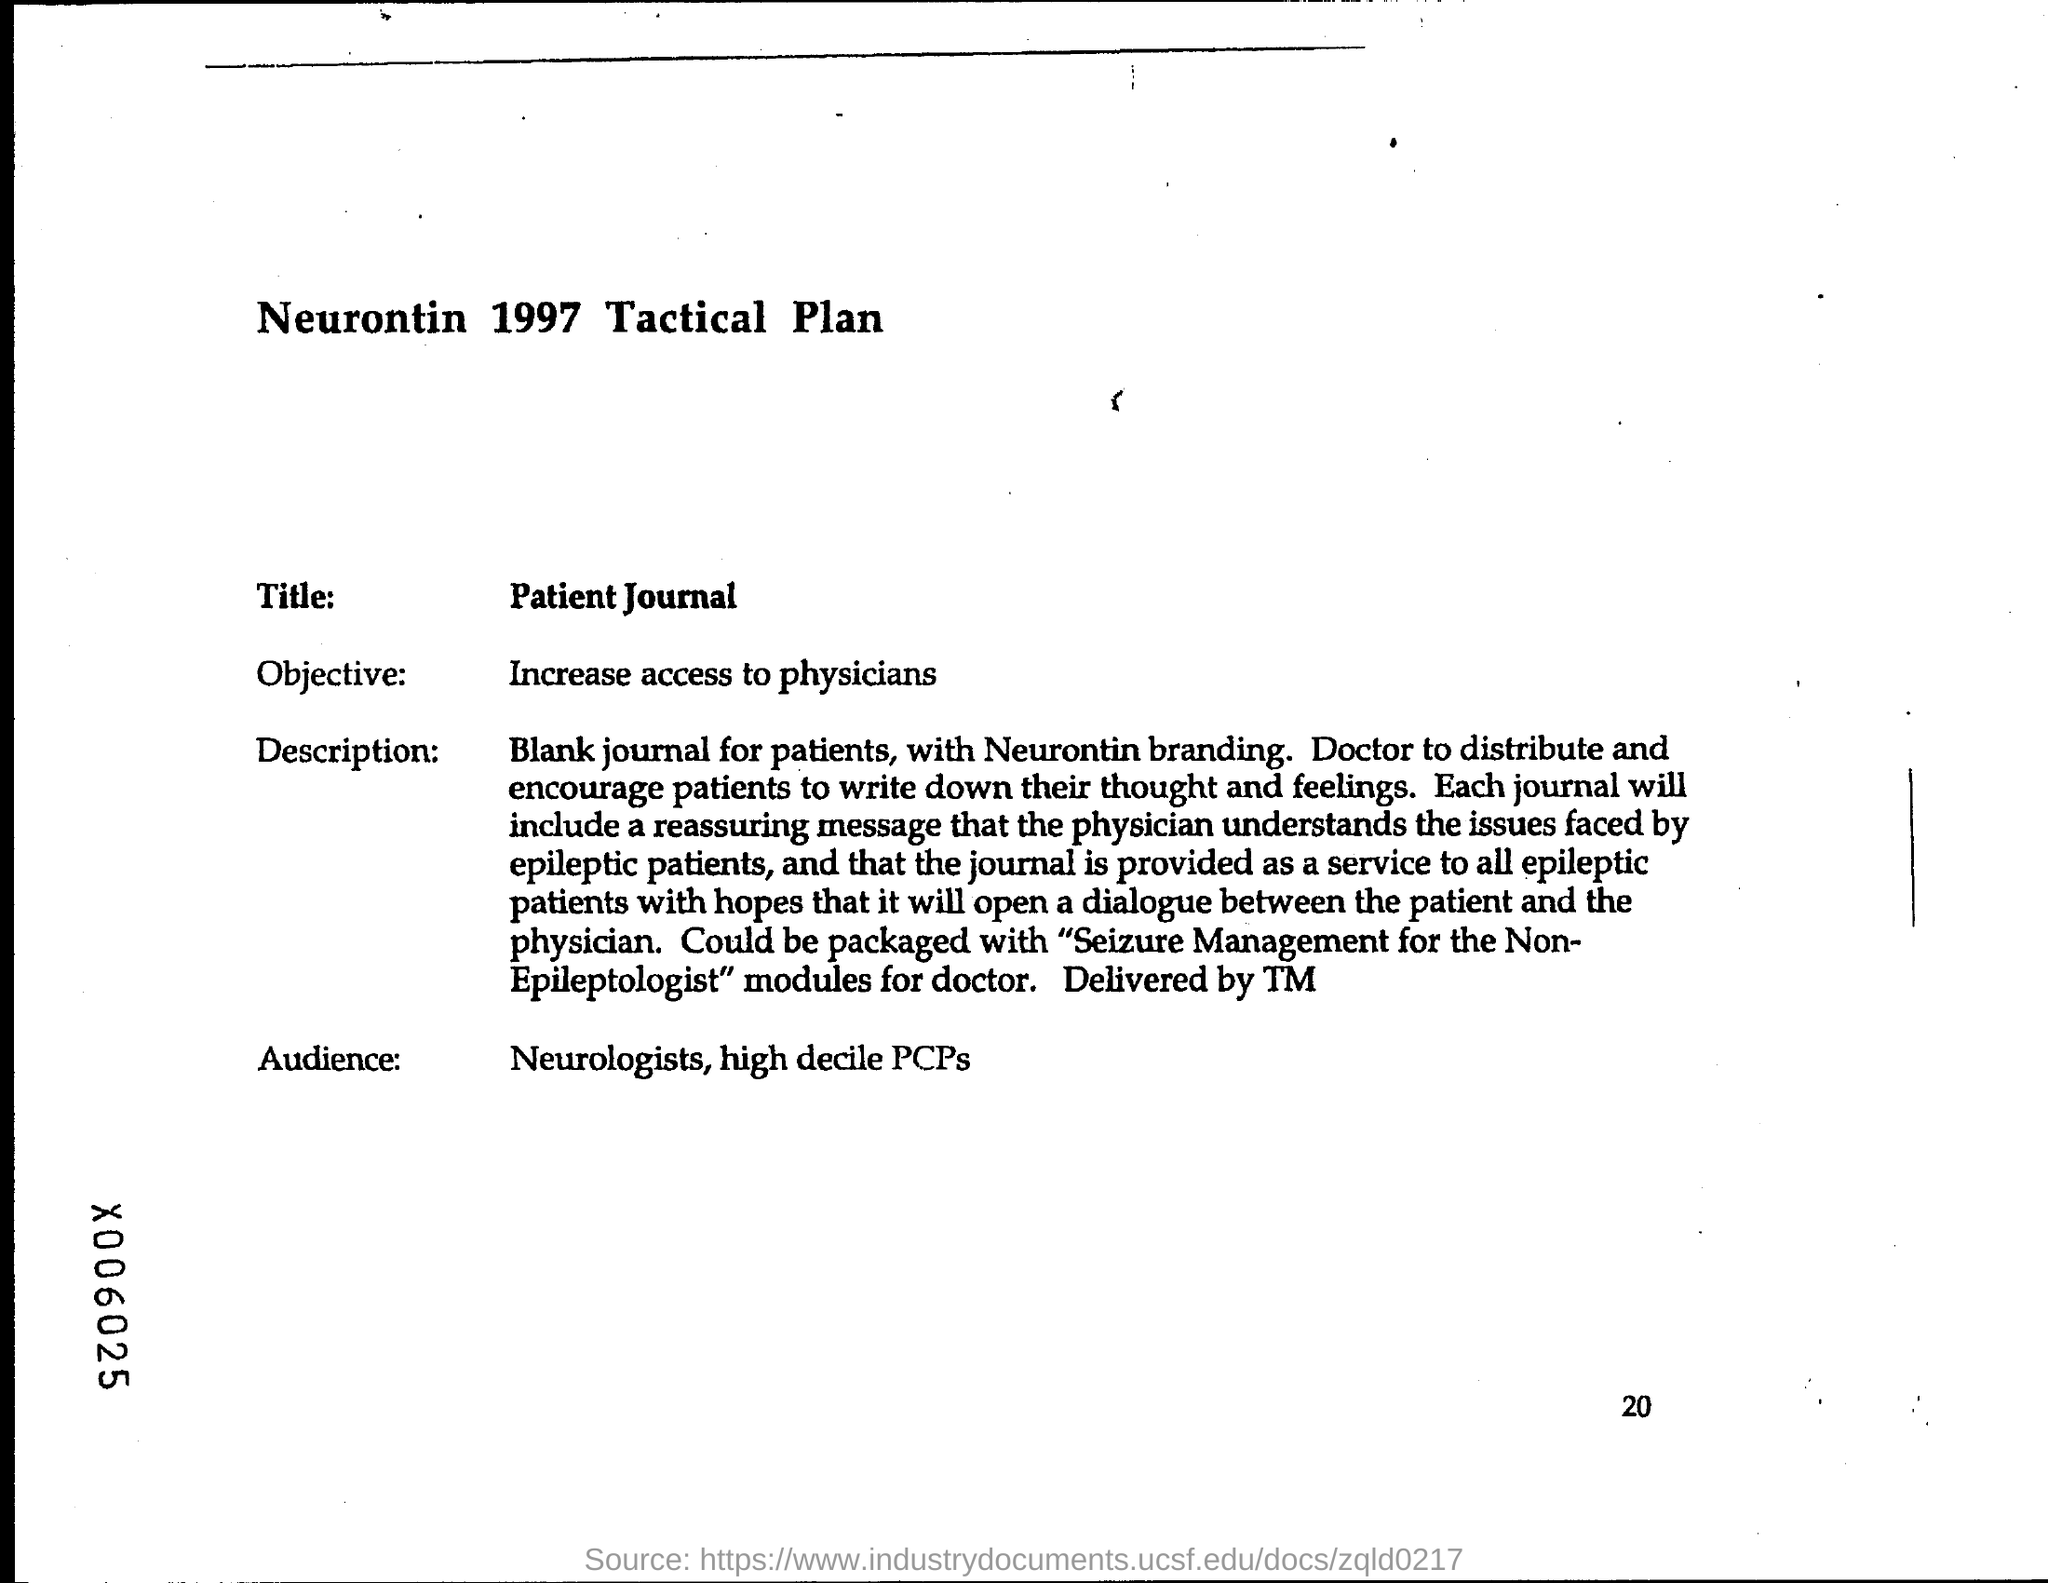Highlight a few significant elements in this photo. The title of this document is the Patient Journal. The page number at the bottom of the page is 20. The objective is to increase access to physicians. 